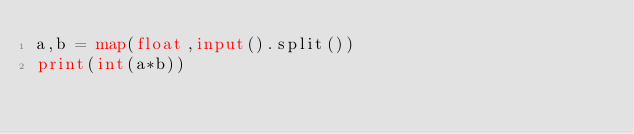<code> <loc_0><loc_0><loc_500><loc_500><_Python_>a,b = map(float,input().split())
print(int(a*b))</code> 